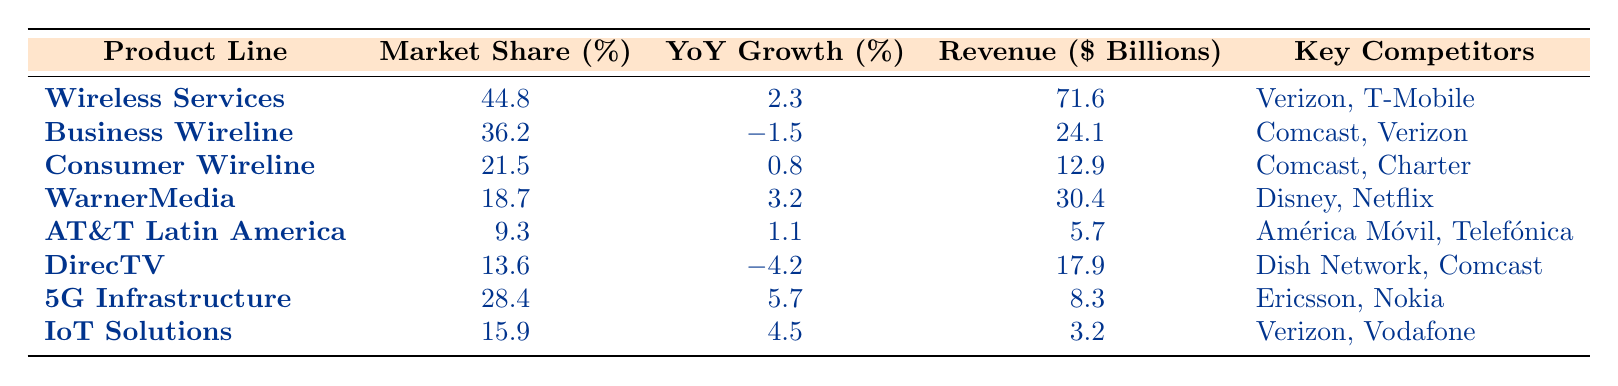What is the market share of AT&T's Wireless Services product line? The table shows that the market share of Wireless Services is listed directly under the "Market Share (%)" column corresponding to the "Wireless Services" product line. It states 44.8%.
Answer: 44.8% Which product line has the highest revenue? By looking at the "Revenue ($ Billions)" column, we can see that Wireless Services has the highest revenue at 71.6 billion dollars, more than any other product line.
Answer: Wireless Services What is the YoY growth percentage for WarnerMedia? Under the "YoY Growth (%)" column, the value corresponding to WarnerMedia in the table is 3.2%. This tells us the yearly growth rate for this product line.
Answer: 3.2% Is the market share of AT&T Latin America greater than that of Consumer Wireline? By comparing the "Market Share (%)" values, AT&T Latin America is at 9.3% and Consumer Wireline is at 21.5%, meaning AT&T Latin America's market share is lower.
Answer: No What is the average YoY growth rate for all product lines? To find the average YoY growth, we add up all the YoY growth percentages from the table: 2.3 + (-1.5) + 0.8 + 3.2 + 1.1 + (-4.2) + 5.7 + 4.5 = 7.9%. There are 8 product lines, so we divide 7.9% by 8 to get the average: 7.9% / 8 = 0.9875%, which rounds to 1.0%.
Answer: 1.0% How many product lines have a market share greater than 15%? Looking through the "Market Share (%)" column, the following product lines exceed 15%: Wireless Services (44.8%), Business Wireline (36.2%), Consumer Wireline (21.5%), WarnerMedia (18.7%), and 5G Infrastructure (28.4%). That counts to 5 product lines.
Answer: 5 Which product line had a negative YoY growth percentage? By inspecting the "YoY Growth (%)" column for negative values, we see that Business Wireline (-1.5%) and DirecTV (-4.2%) have negative growth rates, indicating a decline.
Answer: Business Wireline and DirecTV What is the total revenue from the product lines in wireline services? To find total revenue in wireline services, we consider both Business Wireline and Consumer Wireline. Adding their revenues: 24.1 + 12.9 = 37 billion dollars for wireline services.
Answer: 37 billion dollars 